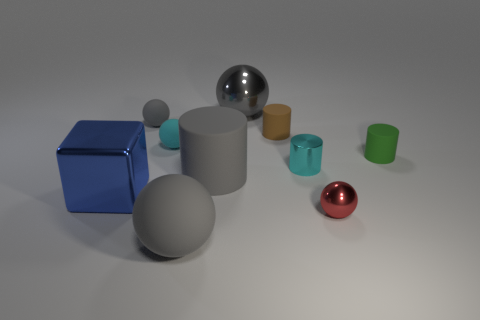Subtract all gray spheres. How many were subtracted if there are1gray spheres left? 2 Subtract all gray rubber balls. How many balls are left? 3 Subtract all green cylinders. How many cylinders are left? 3 Subtract all brown cylinders. How many brown blocks are left? 0 Subtract 3 spheres. How many spheres are left? 2 Subtract all cyan cylinders. Subtract all green cubes. How many cylinders are left? 3 Subtract all small brown metallic objects. Subtract all brown things. How many objects are left? 9 Add 1 tiny green things. How many tiny green things are left? 2 Add 5 large blue objects. How many large blue objects exist? 6 Subtract 0 gray blocks. How many objects are left? 10 